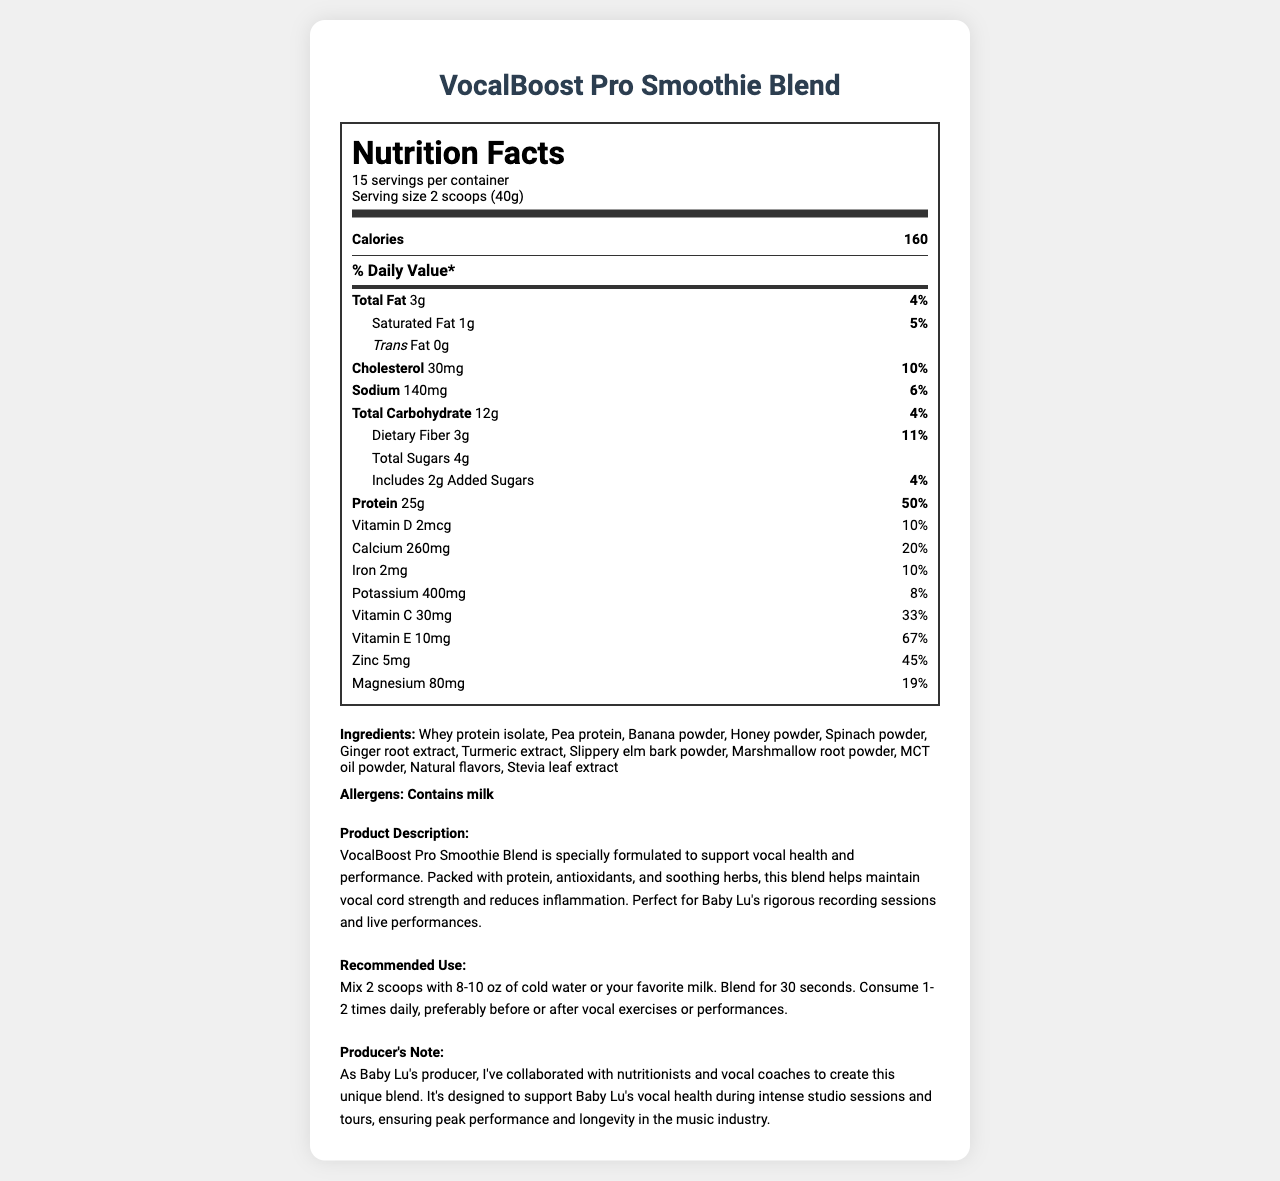what is the serving size? The serving size is clearly stated in the "servings per container" specification section.
Answer: 2 scoops (40g) how many servings per container are there? The document specifies that there are 15 servings per container in the "servings per container" information.
Answer: 15 how many grams of protein are in one serving? In the nutrition section, it states that one serving contains 25g of protein.
Answer: 25g what is the daily value percentage of saturated fat? The nutrition section lists the daily value percentage for saturated fat as 5%.
Answer: 5% what are the two main protein sources? The ingredients section lists whey protein isolate and pea protein as the first two ingredients.
Answer: Whey protein isolate and Pea protein how much vitamin C is in each serving? A. 10mg B. 30mg C. 60mg D. 100mg The document states that each serving contains 30mg of vitamin C.
Answer: B which nutrient has the highest daily value percentage in the smoothie blend? A. Calcium B. Vitamin E C. Protein D. Zinc The daily values are: Calcium - 20%, Vitamin E - 67%, Protein - 50%, Zinc - 45%. Vitamin E has the highest daily value percentage.
Answer: C does this product contain any trans fats? The nutrition label states that the product contains 0g of trans fat.
Answer: No is this product safe for someone with a milk allergy? The allergens section clearly mentions that this product contains milk.
Answer: No summarize the main idea of the VocalBoost Pro Smoothie Blend nutrition facts label. This document provides detailed nutritional information and description of the VocalBoost Pro Smoothie Blend, highlighting its benefits for vocal health, its ingredients, allergen information, and usage instructions.
Answer: VocalBoost Pro Smoothie Blend is a specially formulated smoothie mix designed to support vocal health and performance. It contains 160 calories per serving, with significant amounts of protein (25g, 50% DV) and various vitamins and minerals. The blend is made from both whey and pea protein, along with other ingredients like banana powder, honey powder, and soothing herbs that help maintain vocal cord strength and reduce inflammation. The product contains milk allergens. how many total carbohydrates are in one serving, including dietary fiber and sugars? The nutrition facts state the amount of total carbohydrate is 12g.
Answer: 12g how much zinc is in each serving, and what is its daily value percentage? The nutrition label shows that each serving contains 5mg of zinc, contributing to 45% of the daily value.
Answer: 5mg, 45% what is the recommended way to prepare and consume this smoothie blend? The recommended use section provides detailed instructions on how to prepare and consume the smoothie blend.
Answer: Mix 2 scoops with 8-10 oz of cold water or your favorite milk. Blend for 30 seconds. Consume 1-2 times daily, preferably before or after vocal exercises or performances. what is the main purpose of this smoothie blend according to the product description? The product description states that the blend is formulated to support vocal health and performance.
Answer: To support vocal health and performance. is there any information about the cost of the product on the label? The document does not provide any information about the cost of the product.
Answer: Cannot be determined 